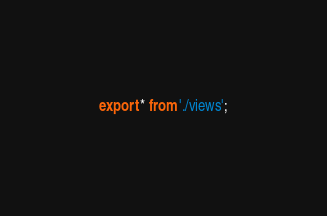Convert code to text. <code><loc_0><loc_0><loc_500><loc_500><_TypeScript_>export * from './views';
</code> 